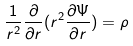Convert formula to latex. <formula><loc_0><loc_0><loc_500><loc_500>\frac { 1 } { r ^ { 2 } } \frac { \partial } { \partial r } ( r ^ { 2 } \frac { \partial \Psi } { \partial r } ) = \rho</formula> 